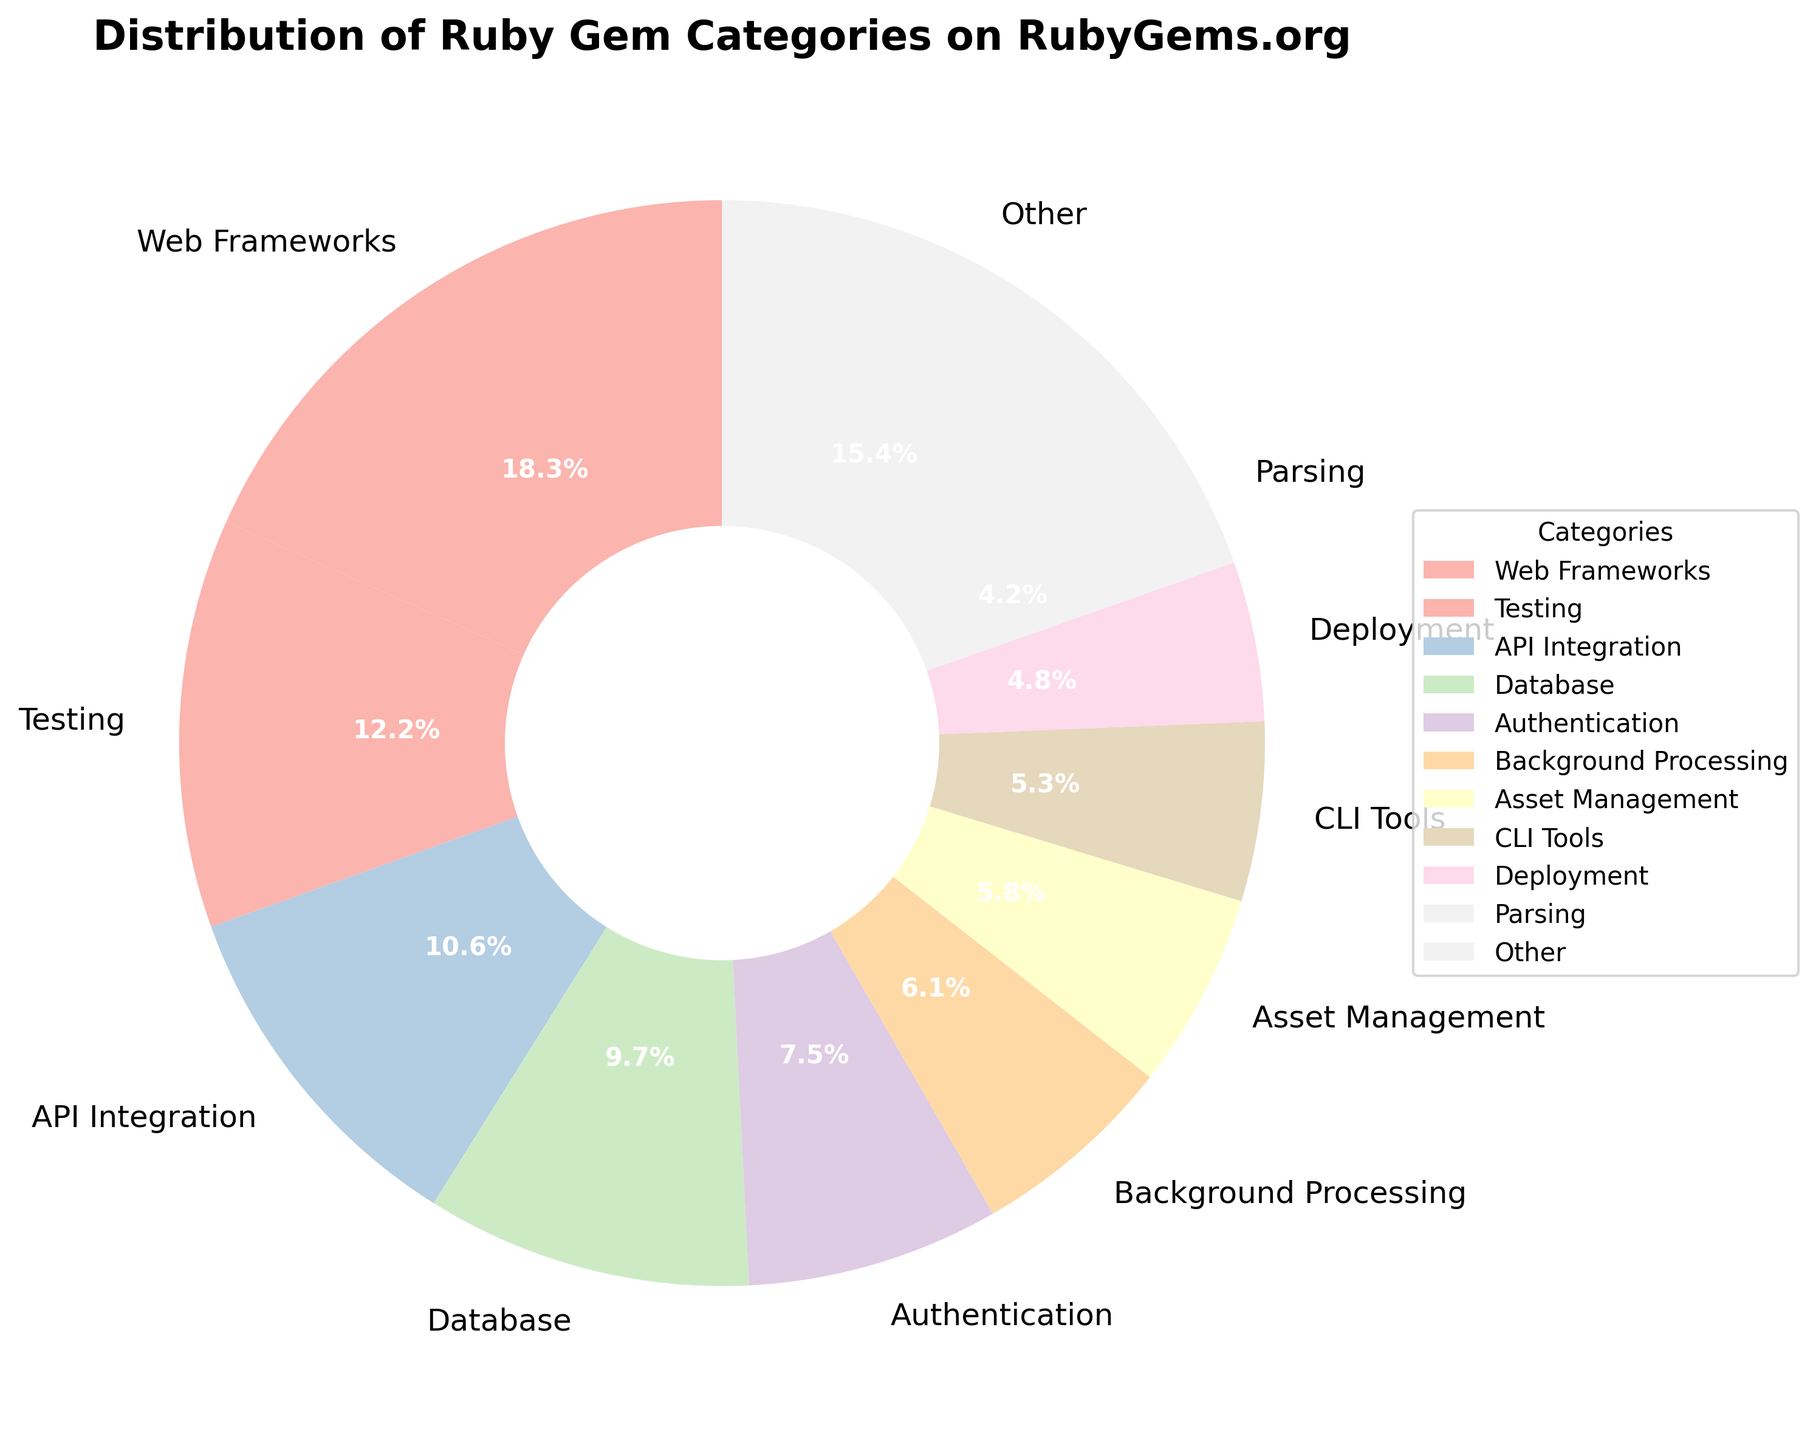What is the percentage of Web Frameworks among the Ruby gem categories? The Web Frameworks category accounts for 18.5% of the total Ruby gem categories, as indicated by the slice of the pie chart labeled with "Web Frameworks" and 18.5%.
Answer: 18.5% Which category has the smallest percentage on the chart? The category with the smallest percentage on the chart is Internationalization, as indicated by the slice labeled "Internationalization" with a percentage of 1.4%.
Answer: Internationalization How does the percentage of Testing compare to that of Database and Authentication combined? To compare, we first sum the percentages of Database and Authentication: 9.8% + 7.6% = 17.4%. The percentage of Testing is 12.3%, which is lower than the combined percentage of Database and Authentication (17.4%).
Answer: Testing is lower What are the categories included in the "Other" group, and what is their combined percentage? The categories in the "Other" group include Parsing, Templating, Security, Caching, Monitoring, Data Visualization, and Internationalization. Their combined percentage is the sum of their individual percentages: 4.2% + 3.7% + 3.1% + 2.8% + 2.5% + 2.1% + 1.4% = 19.8%.
Answer: Parsing, Templating, Security, Caching, Monitoring, Data Visualization, Internationalization (19.8%) What is the total percentage of categories that have less than 5% representation each in the pie chart? The categories with less than 5% representation are Deployment, Parsing, Templating, Security, Caching, Monitoring, Data Visualization, and Internationalization. Summing these percentages: 4.8% + 4.2% + 3.7% + 3.1% + 2.8% + 2.5% + 2.1% + 1.4% = 24.6%.
Answer: 24.6% Which two categories together account for nearly 30% of the Ruby gem categories? Summing up the percentages of the two largest categories, Web Frameworks (18.5%) and Testing (12.3%) gives us 18.5% + 12.3% = 30.8%. Hence, Web Frameworks and Testing together account for nearly 30% of the Ruby gem categories.
Answer: Web Frameworks and Testing What is the difference in percentage between API Integration and Background Processing? The percentage of API Integration is 10.7%, and Background Processing is 6.2%. The difference is calculated as 10.7% - 6.2% = 4.5%.
Answer: 4.5% How do the percentages of CLI Tools and Asset Management compare? The percentage for CLI Tools is 5.4%, and for Asset Management, it's 5.9%. This shows that Asset Management has a slightly higher percentage than CLI Tools.
Answer: Asset Management is higher 